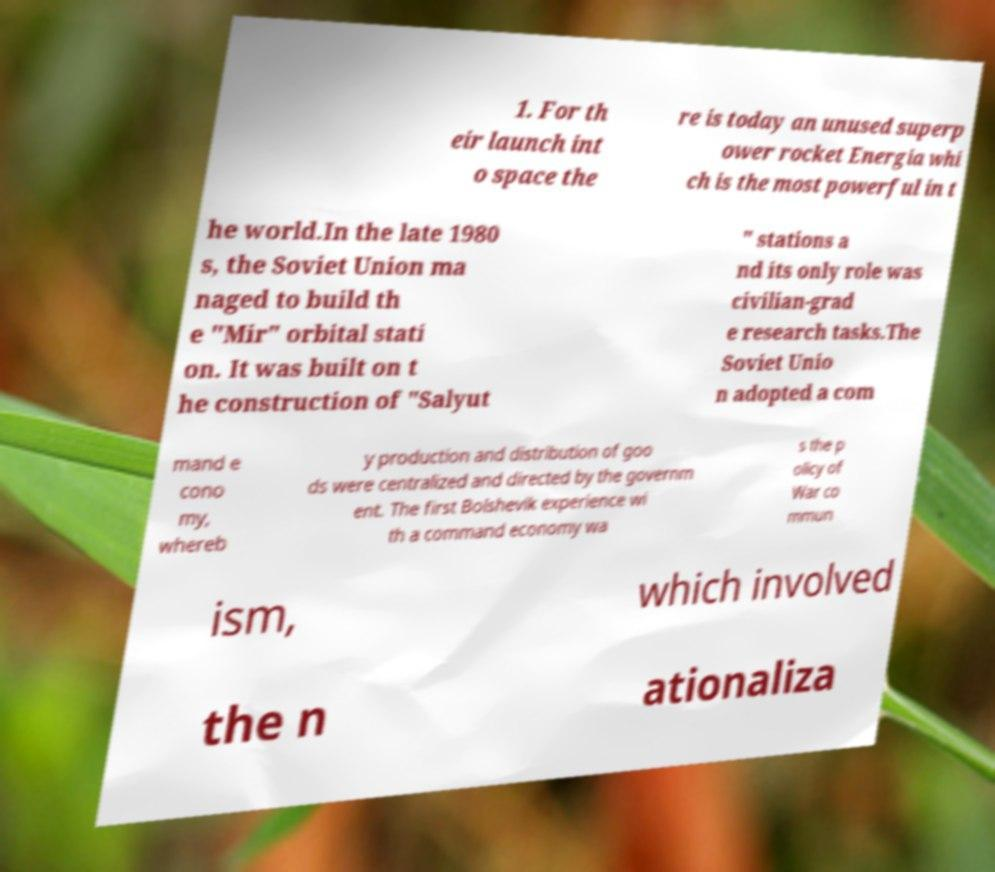There's text embedded in this image that I need extracted. Can you transcribe it verbatim? 1. For th eir launch int o space the re is today an unused superp ower rocket Energia whi ch is the most powerful in t he world.In the late 1980 s, the Soviet Union ma naged to build th e "Mir" orbital stati on. It was built on t he construction of "Salyut " stations a nd its only role was civilian-grad e research tasks.The Soviet Unio n adopted a com mand e cono my, whereb y production and distribution of goo ds were centralized and directed by the governm ent. The first Bolshevik experience wi th a command economy wa s the p olicy of War co mmun ism, which involved the n ationaliza 